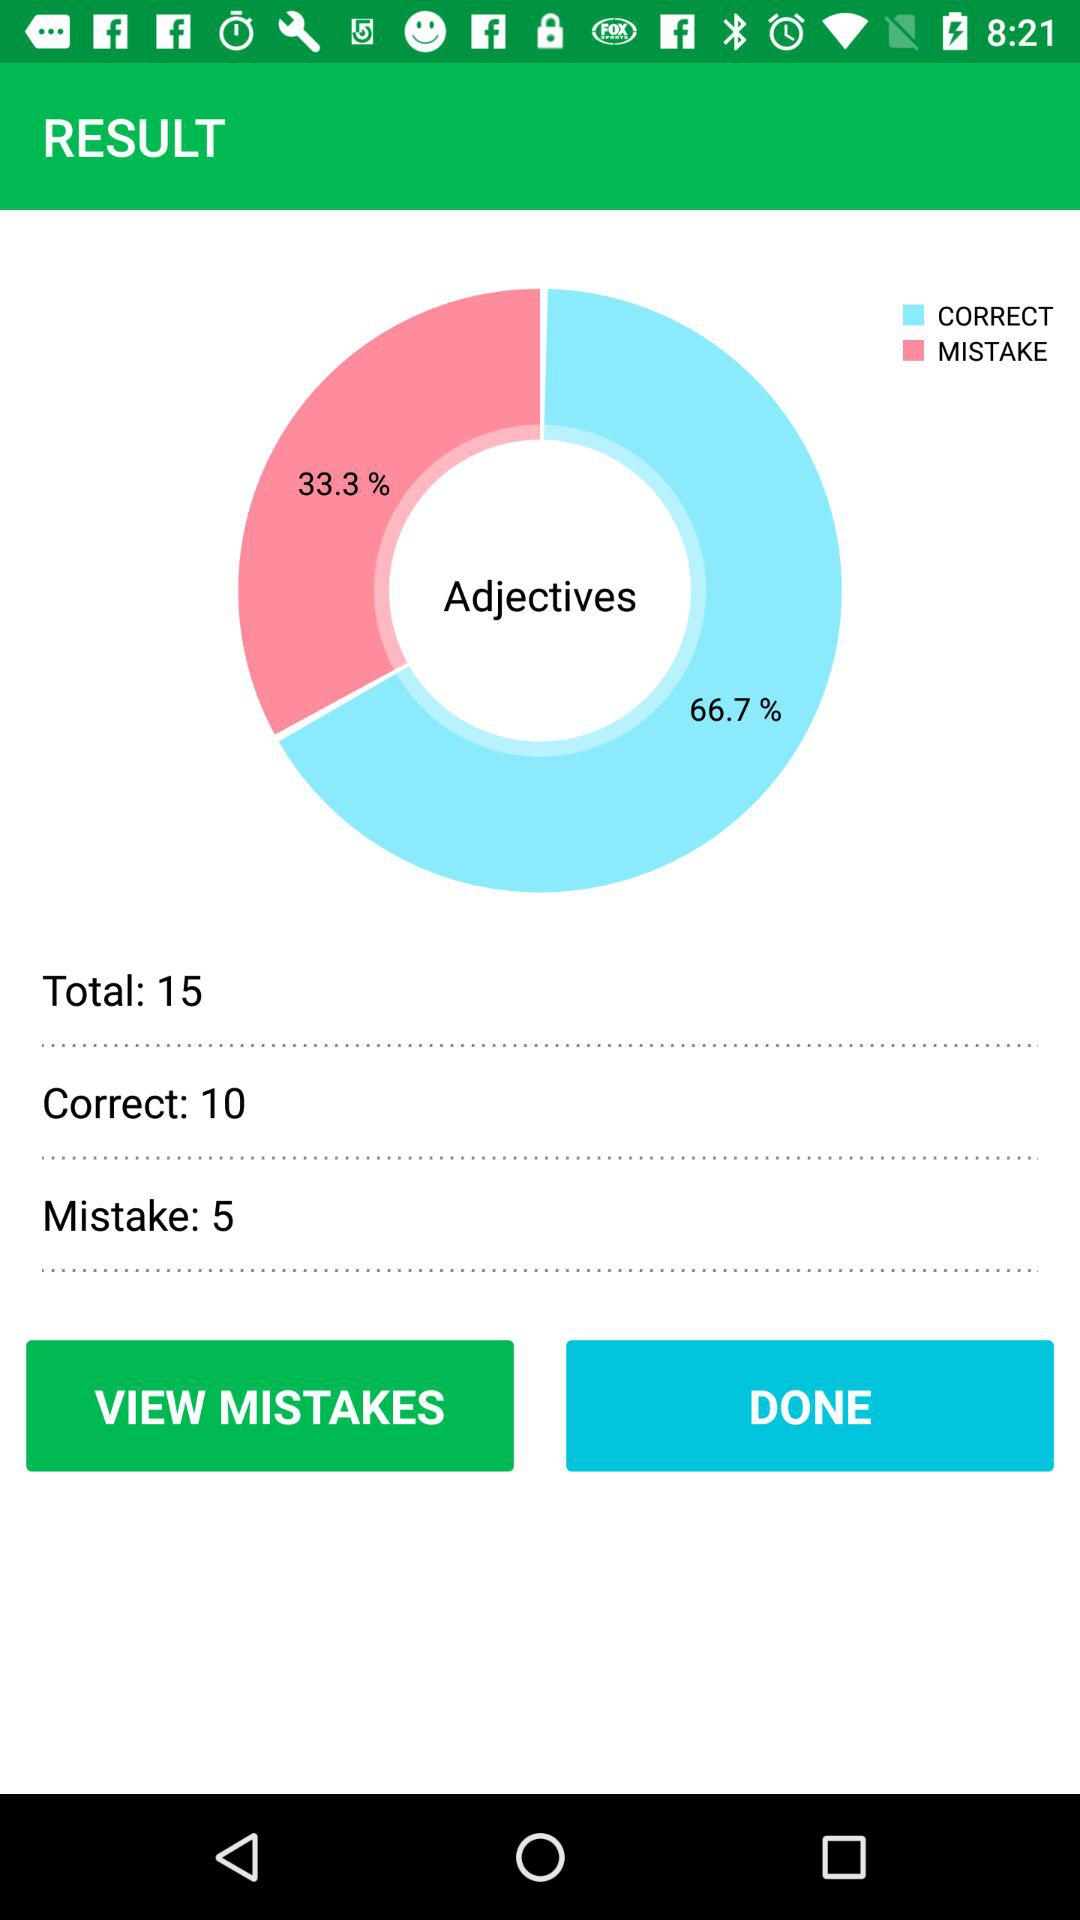What is the number of correct adjectives? The number of correct adjectives is 10. 